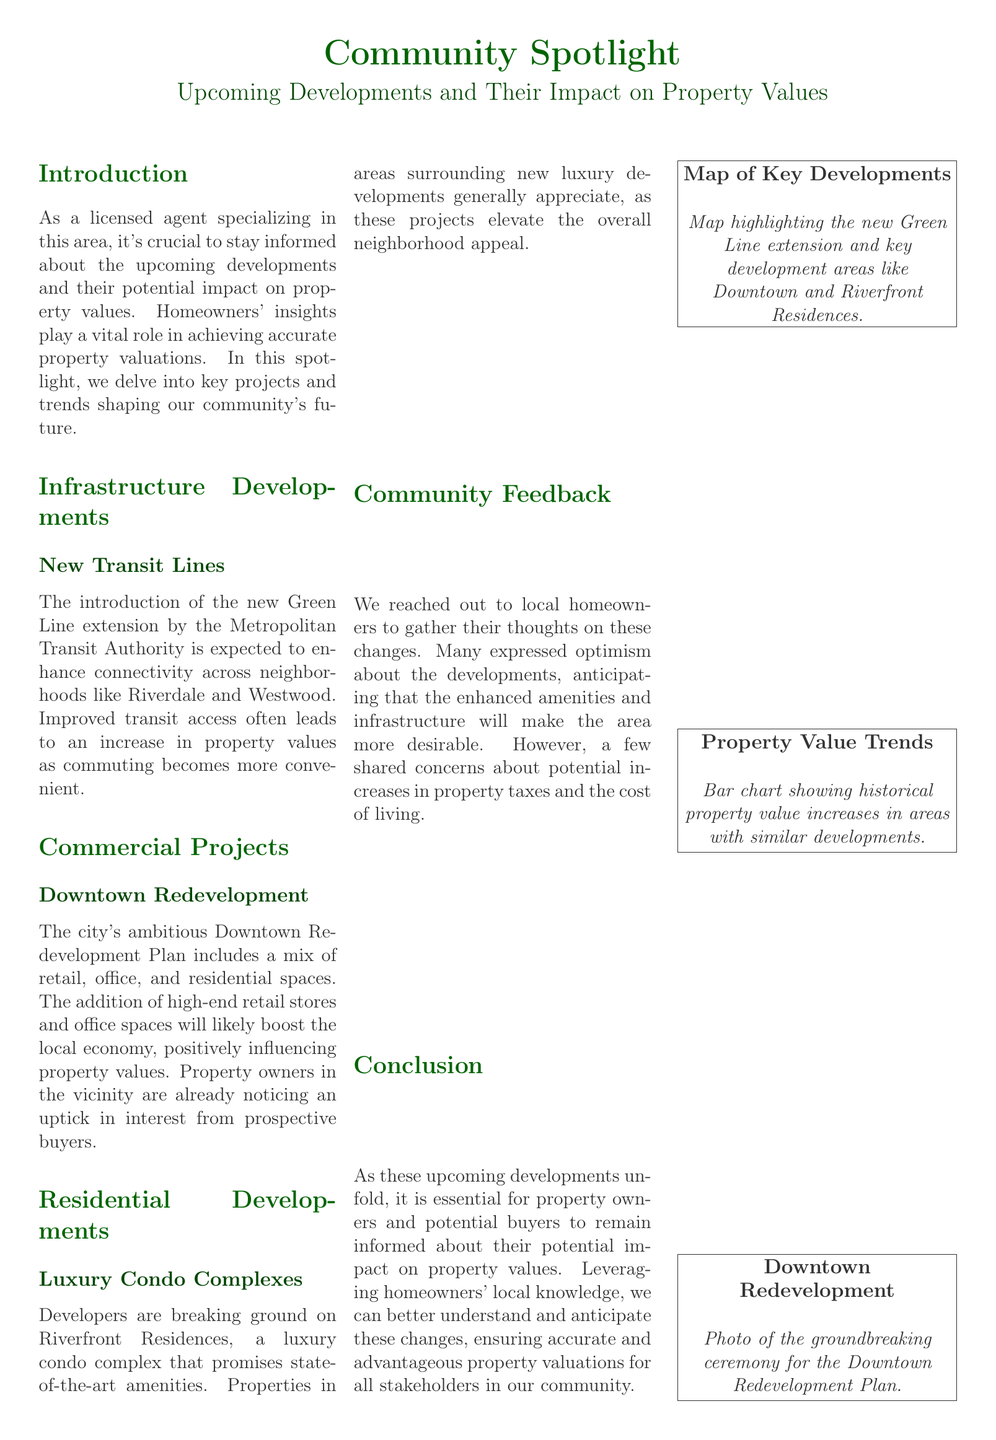What is the name of the new transit line mentioned? The document states the new transit line is the "Green Line extension" by the Metropolitan Transit Authority.
Answer: Green Line extension What is the focus of the Downtown Redevelopment Plan? The Downtown Redevelopment Plan includes a mix of retail, office, and residential spaces as part of its development focus.
Answer: Retail, office, and residential spaces How are local homeowners feeling about the upcoming developments? Many local homeowners have expressed optimism about the upcoming developments, anticipating enhanced amenities and desirability.
Answer: Optimism What is the expected impact of the luxury condos on surrounding properties? The document mentions that properties in areas surrounding new luxury developments generally appreciate, elevating neighborhood appeal.
Answer: Appreciate Which new development is highlighted in the community feedback? The feedback primarily discusses the expected impacts of the new developments on property values and living costs.
Answer: New developments What type of visual information is included in the document? The document includes a map highlighting the new Green Line extension and key development areas like Downtown and Riverfront Residences.
Answer: Map Which section discusses infrastructure developments? The section titled "Infrastructure Developments" discusses infrastructure, including the new transit lines.
Answer: Infrastructure Developments Who authored the document? The document is authored by "A licensed agent specializing in the area," indicating the perspective.
Answer: A licensed agent specializing in the area 